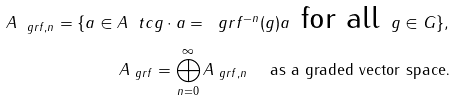<formula> <loc_0><loc_0><loc_500><loc_500>A _ { \ g r f , n } = \{ a \in A \ t c g \cdot a = \ g r f ^ { - n } ( g ) a \text { for all } g \in G \} , \\ A _ { \ g r f } = \bigoplus _ { n = 0 } ^ { \infty } A _ { \ g r f , n } \quad \text { as a graded vector space.}</formula> 